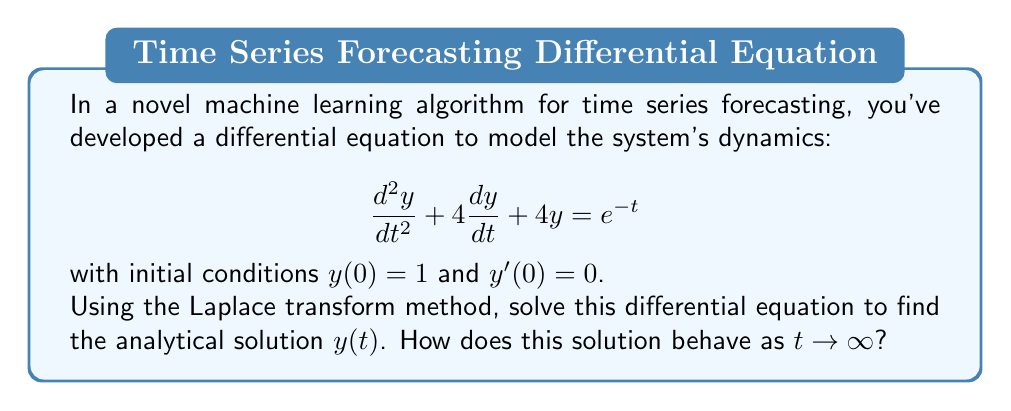Show me your answer to this math problem. Let's solve this step-by-step using the Laplace transform method:

1) First, take the Laplace transform of both sides of the equation:
   $$\mathcal{L}\{y''(t) + 4y'(t) + 4y(t)\} = \mathcal{L}\{e^{-t}\}$$

2) Using Laplace transform properties:
   $$(s^2Y(s) - sy(0) - y'(0)) + 4(sY(s) - y(0)) + 4Y(s) = \frac{1}{s+1}$$

3) Substitute the initial conditions $y(0) = 1$ and $y'(0) = 0$:
   $$(s^2Y(s) - s) + 4(sY(s) - 1) + 4Y(s) = \frac{1}{s+1}$$

4) Simplify:
   $$s^2Y(s) + 4sY(s) + 4Y(s) - s - 4 = \frac{1}{s+1}$$
   $$(s^2 + 4s + 4)Y(s) = \frac{1}{s+1} + s + 4$$

5) Solve for Y(s):
   $$Y(s) = \frac{1}{(s^2 + 4s + 4)(s+1)} + \frac{s + 4}{s^2 + 4s + 4}$$

6) Decompose into partial fractions:
   $$Y(s) = \frac{1}{3(s+1)} - \frac{1}{3(s+2)} + \frac{1}{s+2}$$

7) Take the inverse Laplace transform:
   $$y(t) = \frac{1}{3}e^{-t} - \frac{1}{3}e^{-2t} + e^{-2t}$$

8) Simplify:
   $$y(t) = \frac{1}{3}e^{-t} + \frac{2}{3}e^{-2t}$$

As $t \to \infty$, both exponential terms approach zero, so $y(t) \to 0$.
Answer: $y(t) = \frac{1}{3}e^{-t} + \frac{2}{3}e^{-2t}$; $y(t) \to 0$ as $t \to \infty$ 